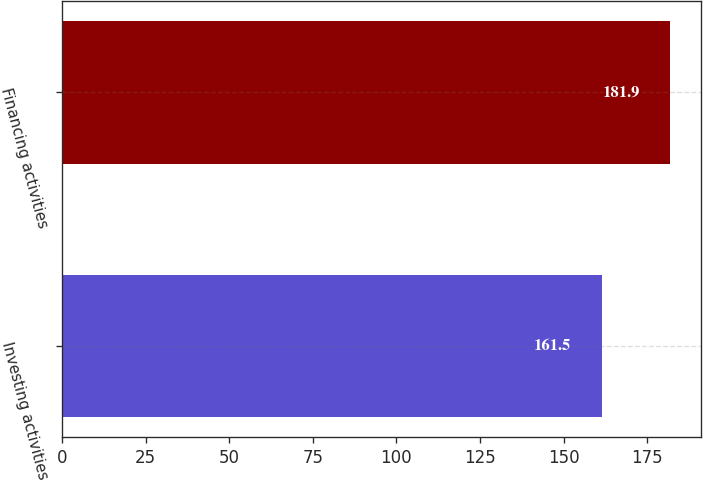Convert chart to OTSL. <chart><loc_0><loc_0><loc_500><loc_500><bar_chart><fcel>Investing activities<fcel>Financing activities<nl><fcel>161.5<fcel>181.9<nl></chart> 